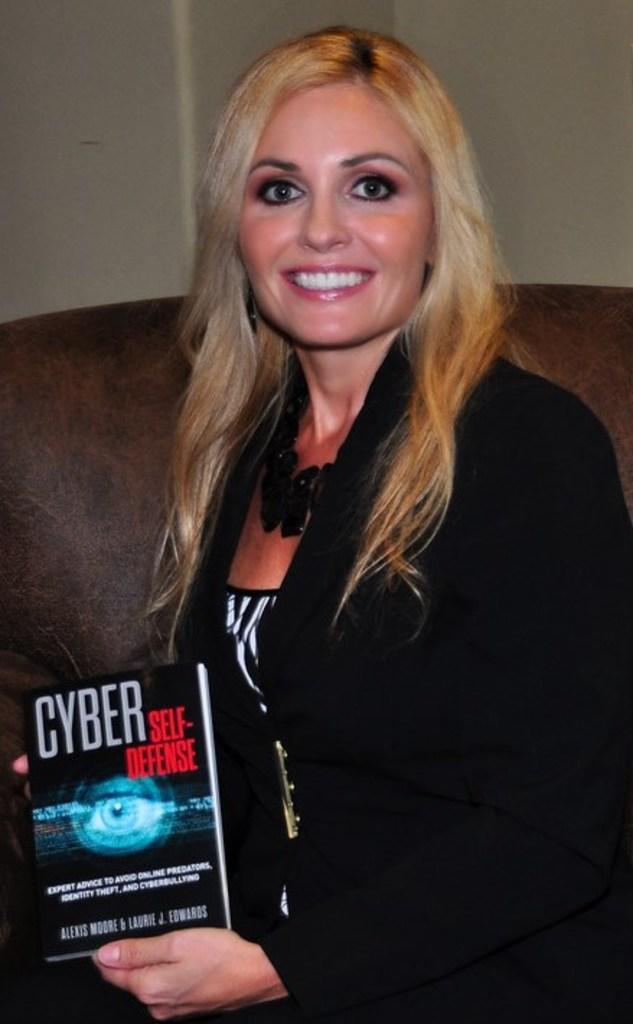Describe this image in one or two sentences. In this picture we can see a woman, she is smiling and she is holding a book. 